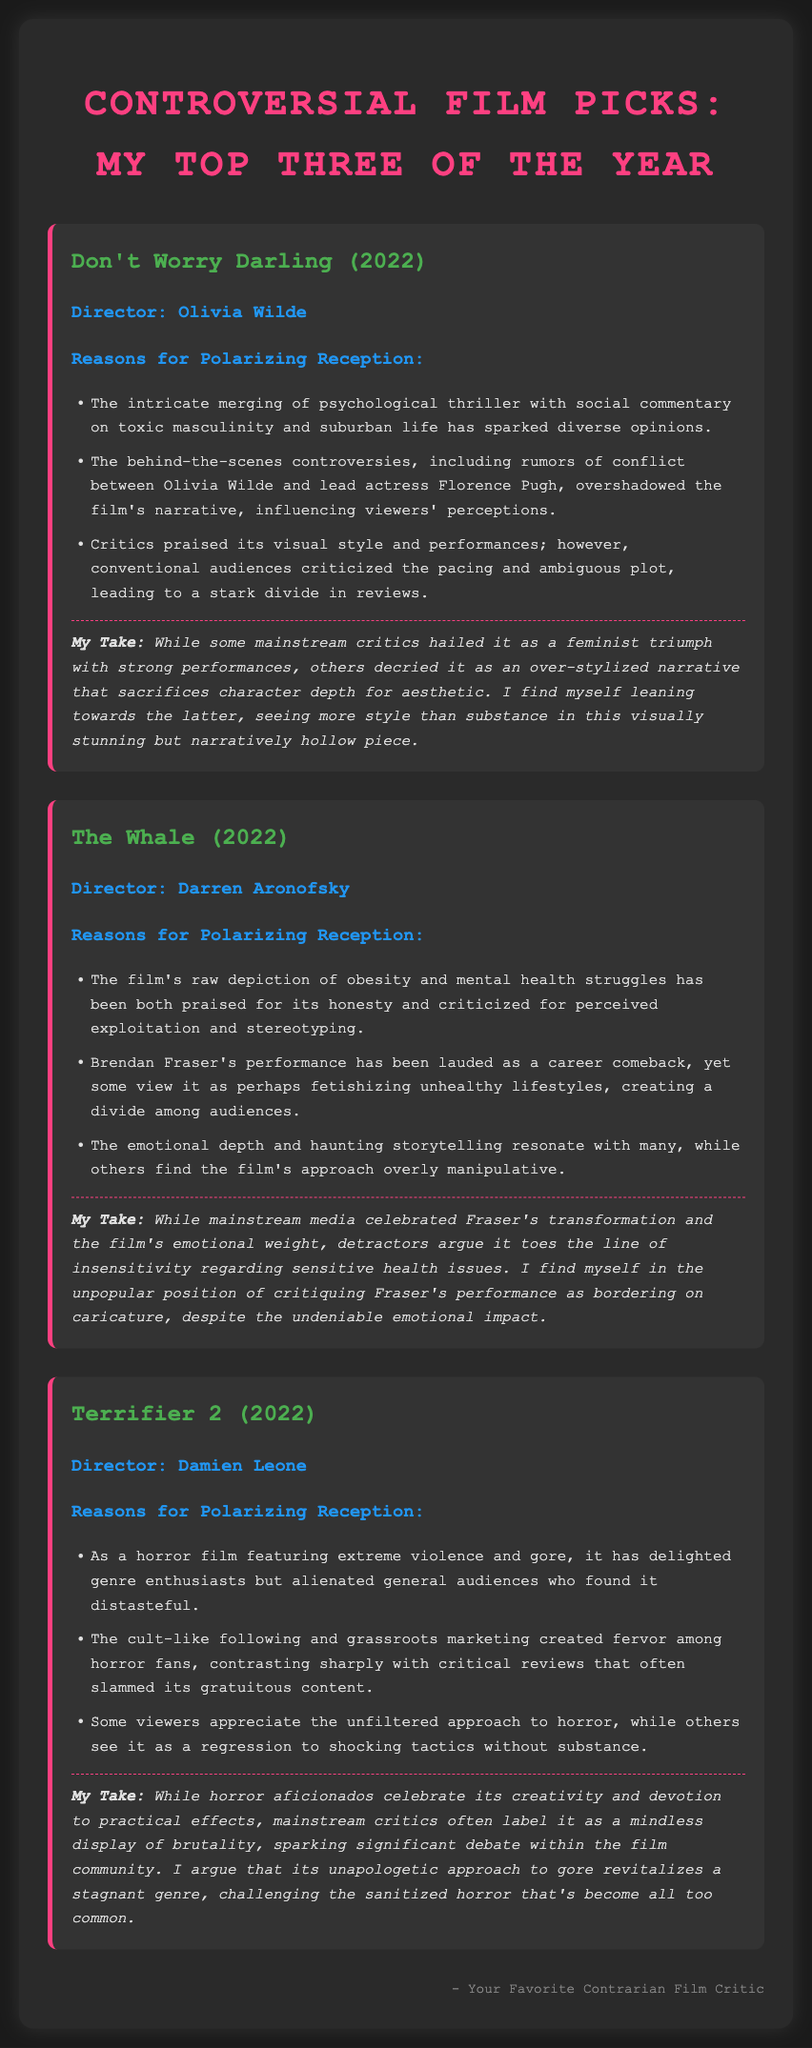What is the first film listed? The first film mentioned in the note is "Don't Worry Darling (2022)."
Answer: Don't Worry Darling (2022) Who is the director of "The Whale"? The director of "The Whale" is Darren Aronofsky.
Answer: Darren Aronofsky What genre does "Terrifier 2" belong to? "Terrifier 2" is categorized as a horror film.
Answer: Horror What is a reason for the polarizing reception of "The Whale"? One reason is the film's raw depiction of obesity and mental health struggles, which some see as exploitation.
Answer: Raw depiction of obesity and mental health struggles According to the document, what did critics say about the visual style of "Don't Worry Darling"? Critics praised its visual style, but conventional audiences criticized its pacing and ambiguous plot.
Answer: Praised What unique aspect of "Terrifier 2" is mentioned regarding its marketing? The marketing of "Terrifier 2" is described as grassroots, creating fervor among horror fans.
Answer: Grassroots marketing What sentiment does the author express about "The Whale's" emotional impact? The author acknowledges the emotional impact but critiques Brendan Fraser's performance as bordering on caricature.
Answer: Bordering on caricature Which film does the author believe revitalizes its genre? The author argues that "Terrifier 2" revitalizes the horror genre with its unapologetic approach to gore.
Answer: Terrifier 2 What is the signature line of the document? The signature line is "Your Favorite Contrarian Film Critic."
Answer: Your Favorite Contrarian Film Critic 